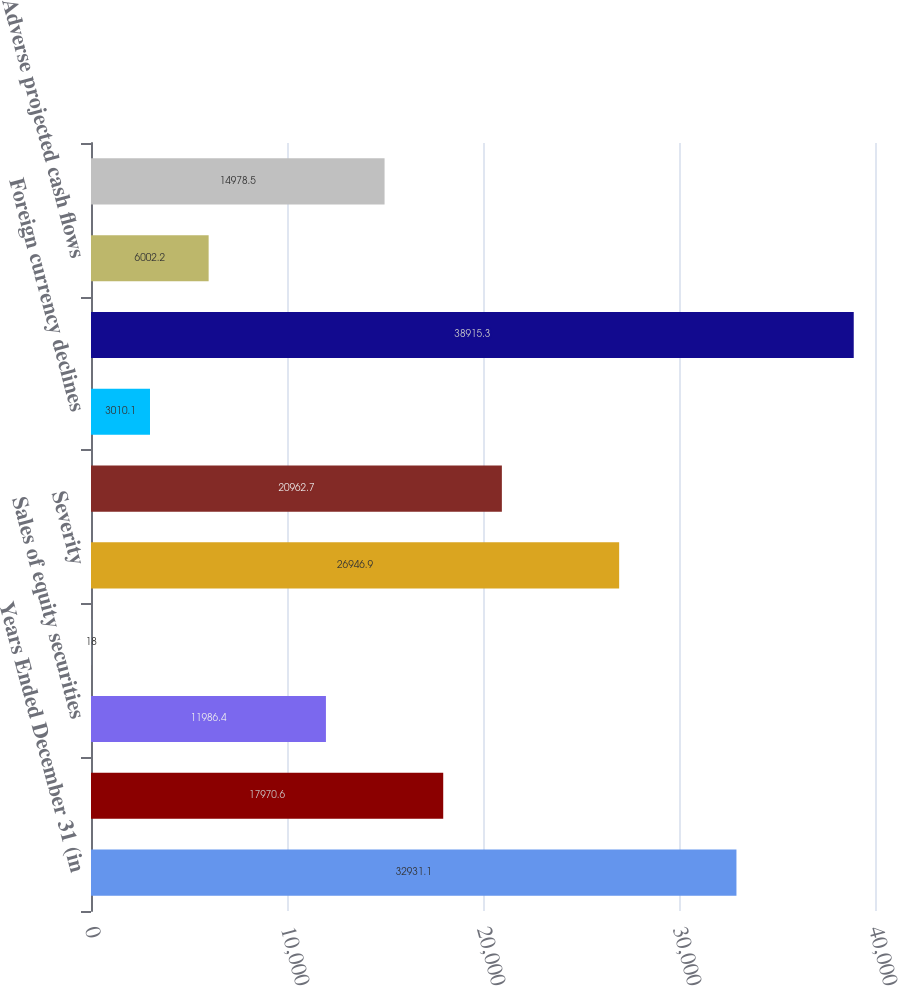Convert chart to OTSL. <chart><loc_0><loc_0><loc_500><loc_500><bar_chart><fcel>Years Ended December 31 (in<fcel>Sales of fixed maturity<fcel>Sales of equity securities<fcel>Sales of real estate and loans<fcel>Severity<fcel>Change in intent<fcel>Foreign currency declines<fcel>Issuer-specific credit events<fcel>Adverse projected cash flows<fcel>Foreign exchange transactions<nl><fcel>32931.1<fcel>17970.6<fcel>11986.4<fcel>18<fcel>26946.9<fcel>20962.7<fcel>3010.1<fcel>38915.3<fcel>6002.2<fcel>14978.5<nl></chart> 